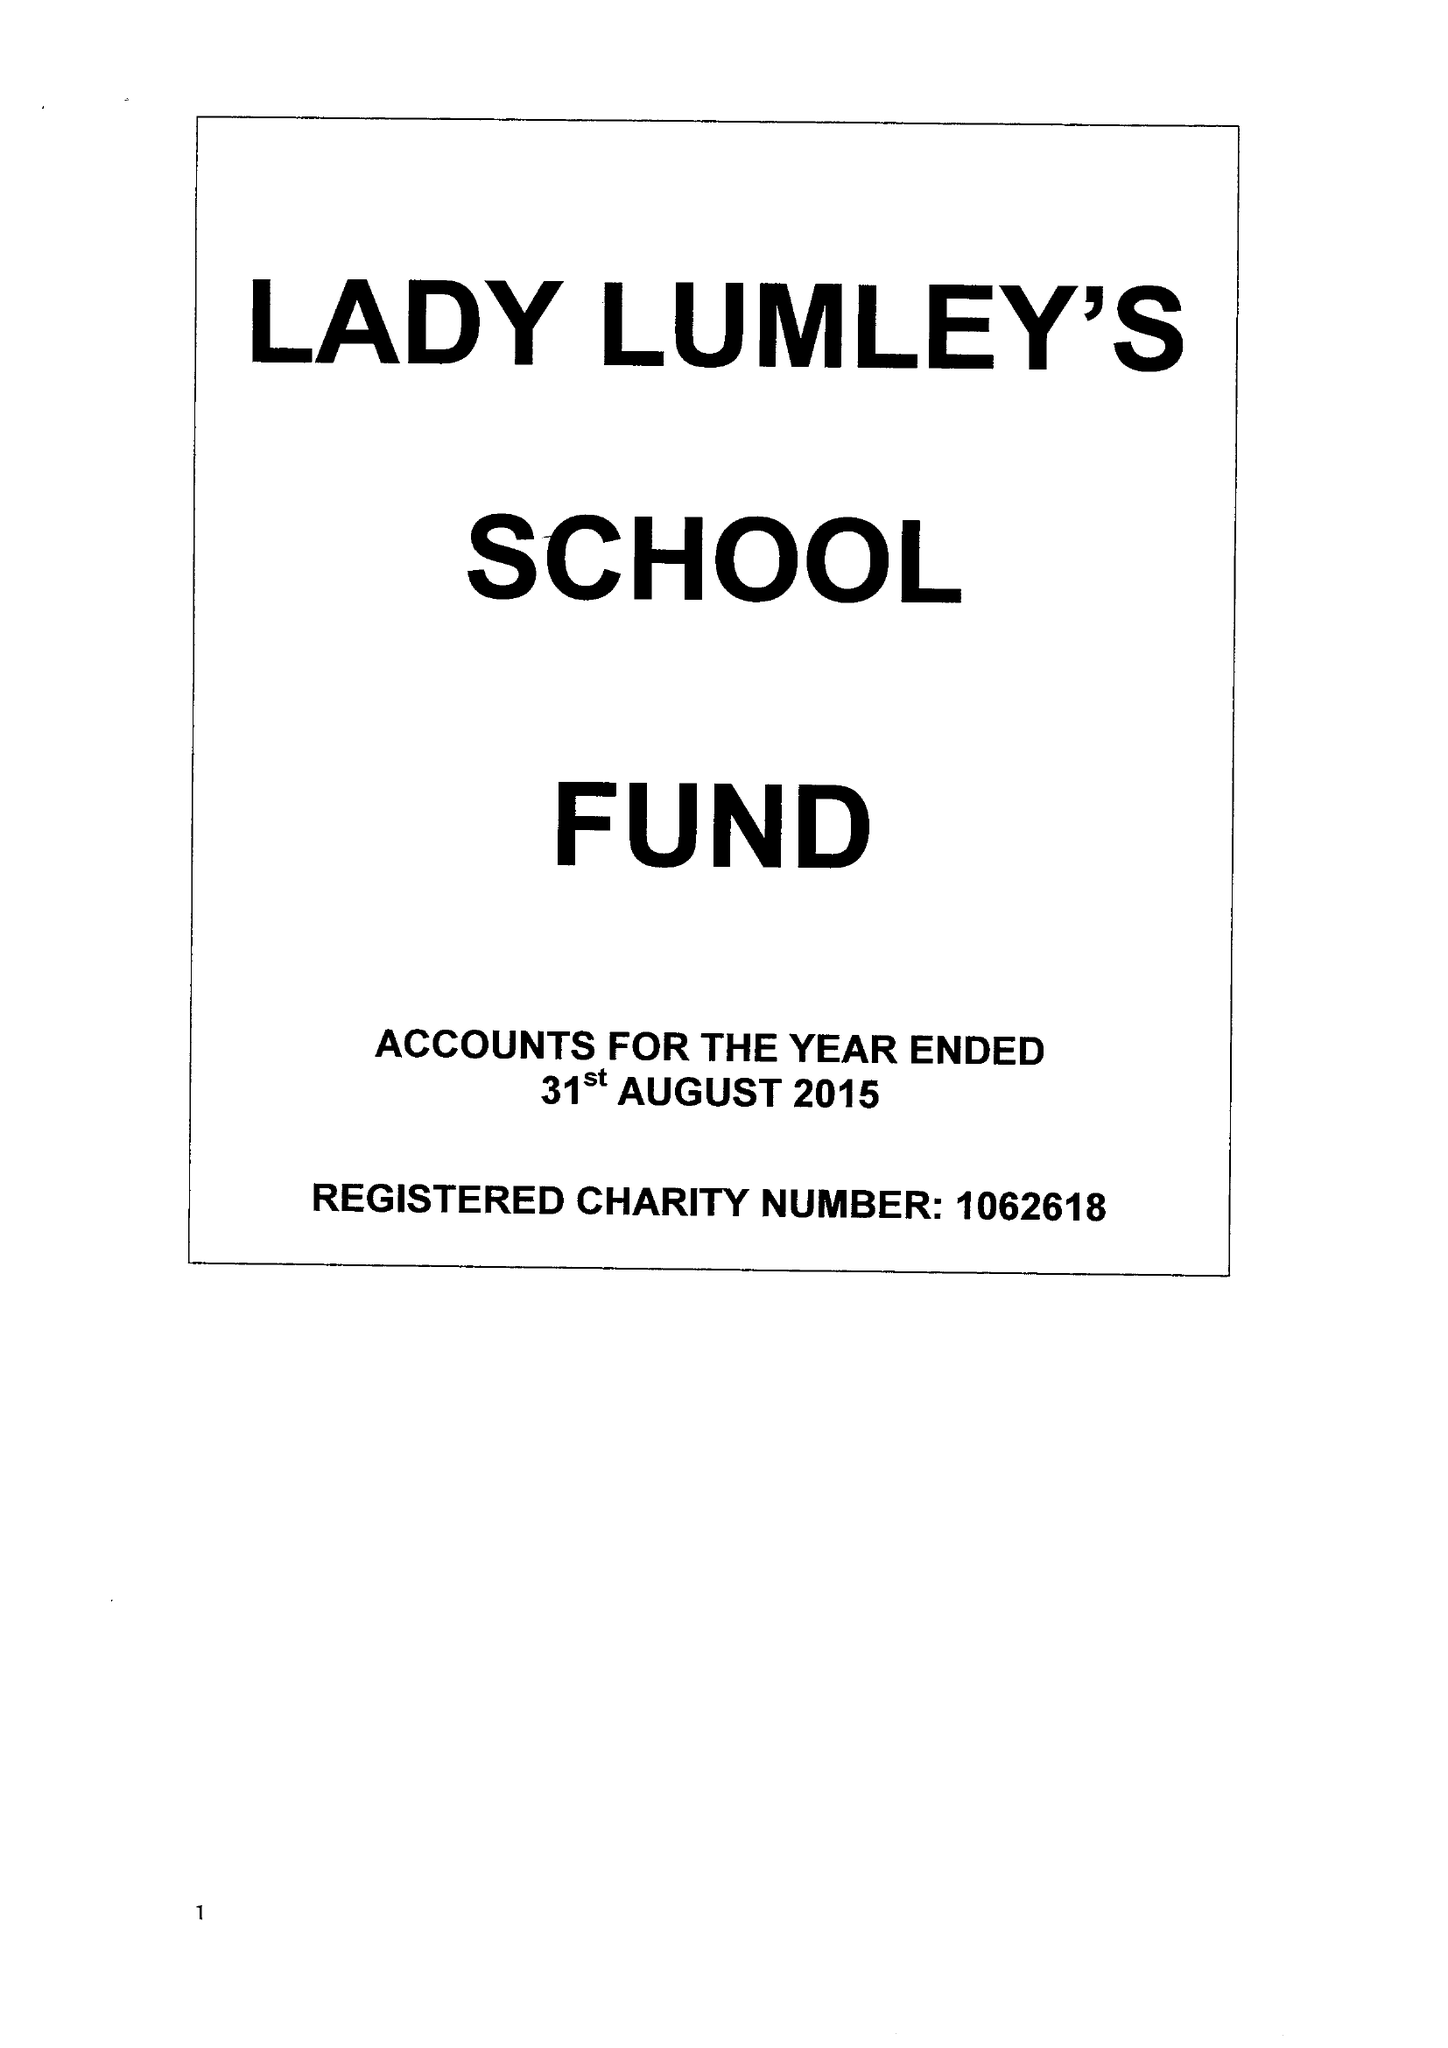What is the value for the address__street_line?
Answer the question using a single word or phrase. SWAINSEA LANE 